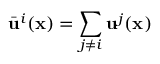<formula> <loc_0><loc_0><loc_500><loc_500>\bar { u } ^ { i } ( x ) = \sum _ { j \neq i } u ^ { j } ( x )</formula> 